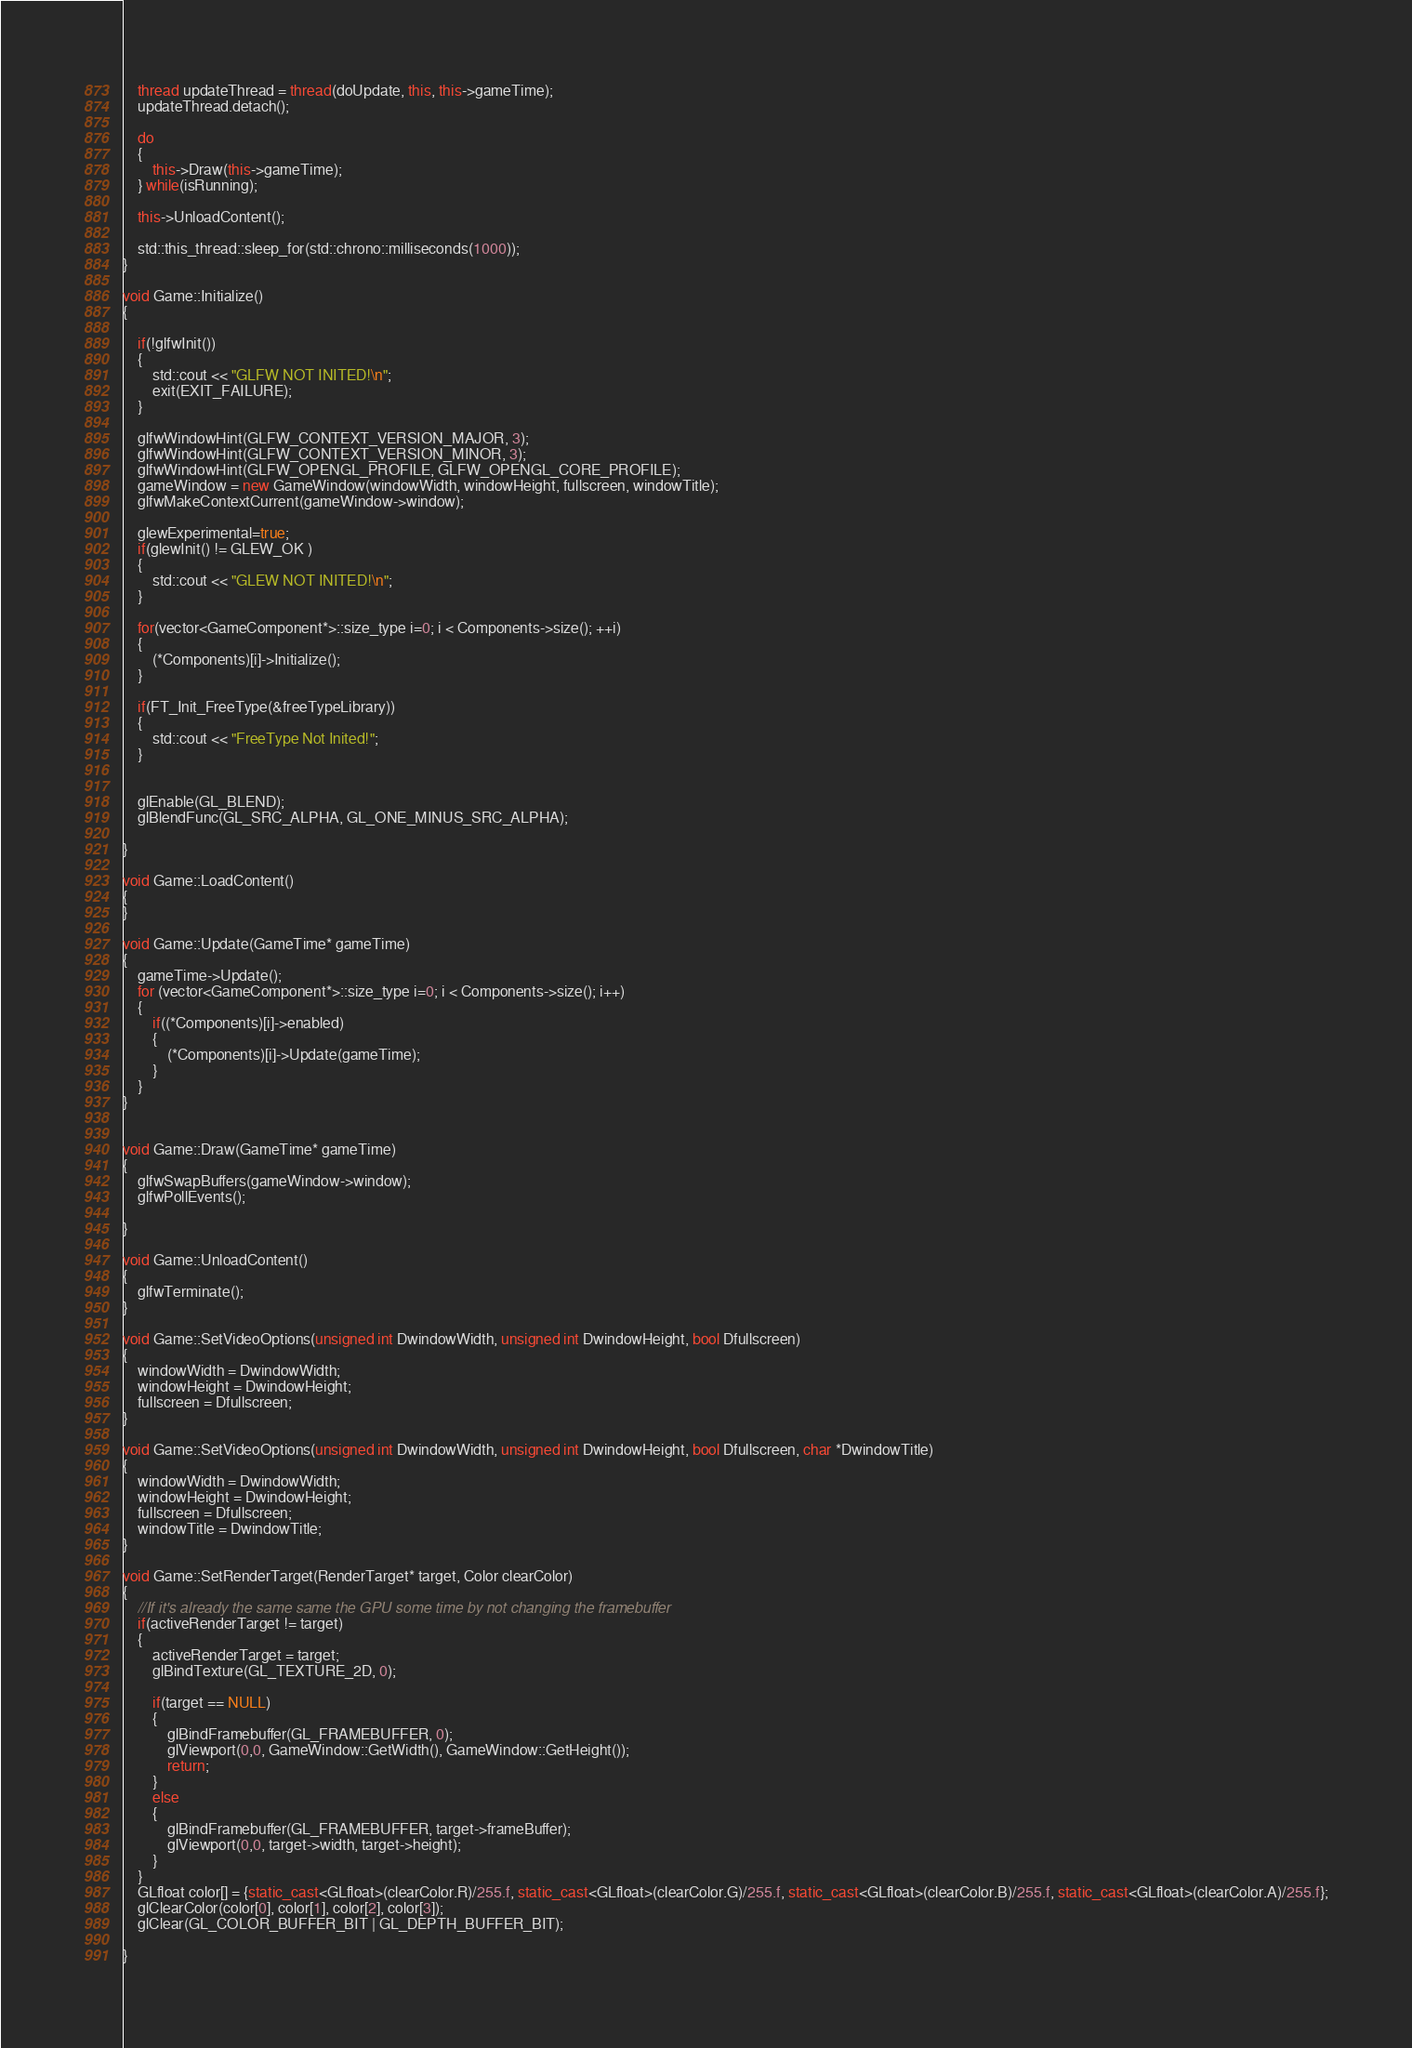<code> <loc_0><loc_0><loc_500><loc_500><_C++_>	thread updateThread = thread(doUpdate, this, this->gameTime);
	updateThread.detach();

	do
	{
		this->Draw(this->gameTime);
	} while(isRunning);

	this->UnloadContent();

	std::this_thread::sleep_for(std::chrono::milliseconds(1000));
}

void Game::Initialize()
{

	if(!glfwInit())
	{
		std::cout << "GLFW NOT INITED!\n";
		exit(EXIT_FAILURE);
	}	

	glfwWindowHint(GLFW_CONTEXT_VERSION_MAJOR, 3);
	glfwWindowHint(GLFW_CONTEXT_VERSION_MINOR, 3);
	glfwWindowHint(GLFW_OPENGL_PROFILE, GLFW_OPENGL_CORE_PROFILE);
	gameWindow = new GameWindow(windowWidth, windowHeight, fullscreen, windowTitle);
	glfwMakeContextCurrent(gameWindow->window);

	glewExperimental=true;
	if(glewInit() != GLEW_OK )
	{
		std::cout << "GLEW NOT INITED!\n";
	}

	for(vector<GameComponent*>::size_type i=0; i < Components->size(); ++i)
	{
		(*Components)[i]->Initialize();
	}

	if(FT_Init_FreeType(&freeTypeLibrary))
	{
		std::cout << "FreeType Not Inited!";
	}


	glEnable(GL_BLEND);
	glBlendFunc(GL_SRC_ALPHA, GL_ONE_MINUS_SRC_ALPHA);

}

void Game::LoadContent()
{
}

void Game::Update(GameTime* gameTime)
{
	gameTime->Update();
	for (vector<GameComponent*>::size_type i=0; i < Components->size(); i++)
	{
		if((*Components)[i]->enabled)
		{
			(*Components)[i]->Update(gameTime);
		}
	}
}


void Game::Draw(GameTime* gameTime)
{
	glfwSwapBuffers(gameWindow->window);
	glfwPollEvents();

}

void Game::UnloadContent()
{
	glfwTerminate();
}

void Game::SetVideoOptions(unsigned int DwindowWidth, unsigned int DwindowHeight, bool Dfullscreen)
{
	windowWidth = DwindowWidth;
	windowHeight = DwindowHeight;
	fullscreen = Dfullscreen;
}

void Game::SetVideoOptions(unsigned int DwindowWidth, unsigned int DwindowHeight, bool Dfullscreen, char *DwindowTitle)
{
	windowWidth = DwindowWidth;
	windowHeight = DwindowHeight;
	fullscreen = Dfullscreen;
	windowTitle = DwindowTitle;
}

void Game::SetRenderTarget(RenderTarget* target, Color clearColor)
{
	//If it's already the same same the GPU some time by not changing the framebuffer
	if(activeRenderTarget != target)
	{
		activeRenderTarget = target;
		glBindTexture(GL_TEXTURE_2D, 0);

		if(target == NULL)
		{
			glBindFramebuffer(GL_FRAMEBUFFER, 0);
			glViewport(0,0, GameWindow::GetWidth(), GameWindow::GetHeight());
			return;
		}
		else
		{
			glBindFramebuffer(GL_FRAMEBUFFER, target->frameBuffer);
			glViewport(0,0, target->width, target->height);
		}
	}
	GLfloat color[] = {static_cast<GLfloat>(clearColor.R)/255.f, static_cast<GLfloat>(clearColor.G)/255.f, static_cast<GLfloat>(clearColor.B)/255.f, static_cast<GLfloat>(clearColor.A)/255.f};
	glClearColor(color[0], color[1], color[2], color[3]);
	glClear(GL_COLOR_BUFFER_BIT | GL_DEPTH_BUFFER_BIT);

}
</code> 